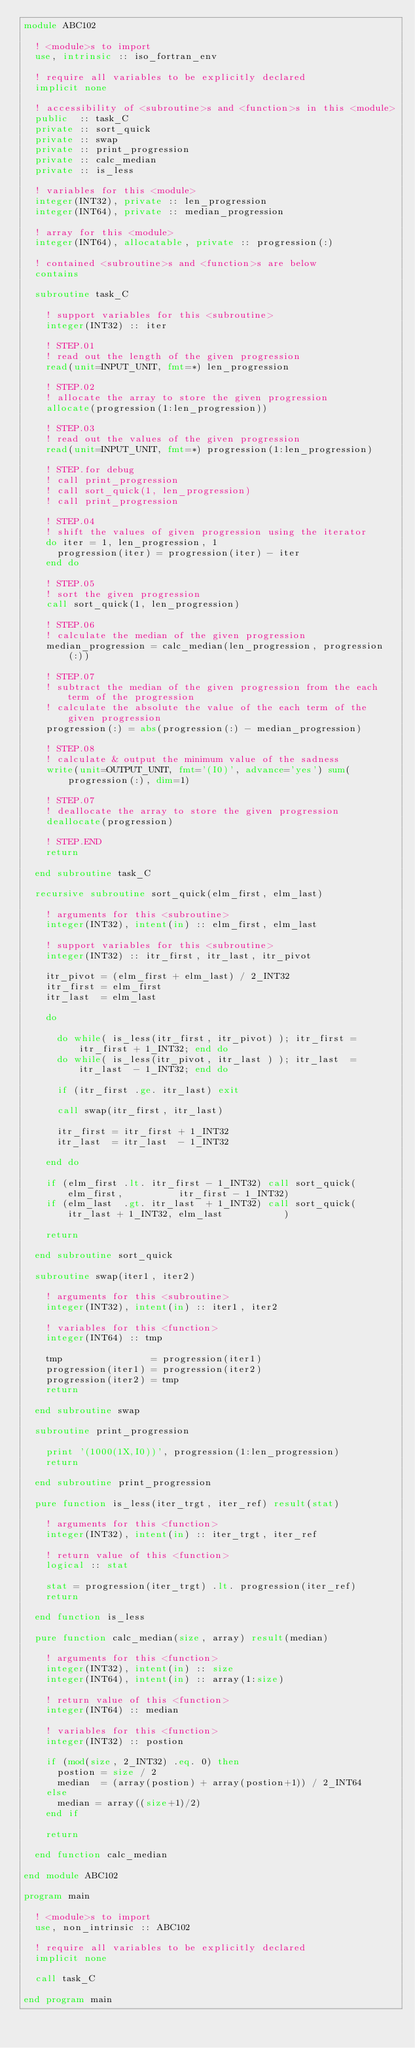Convert code to text. <code><loc_0><loc_0><loc_500><loc_500><_FORTRAN_>module ABC102

  ! <module>s to import
  use, intrinsic :: iso_fortran_env

  ! require all variables to be explicitly declared
  implicit none

  ! accessibility of <subroutine>s and <function>s in this <module>
  public  :: task_C
  private :: sort_quick
  private :: swap
  private :: print_progression
  private :: calc_median
  private :: is_less

  ! variables for this <module>
  integer(INT32), private :: len_progression
  integer(INT64), private :: median_progression

  ! array for this <module>
  integer(INT64), allocatable, private :: progression(:)

  ! contained <subroutine>s and <function>s are below
  contains

  subroutine task_C

    ! support variables for this <subroutine>
    integer(INT32) :: iter

    ! STEP.01
    ! read out the length of the given progression
    read(unit=INPUT_UNIT, fmt=*) len_progression

    ! STEP.02
    ! allocate the array to store the given progression
    allocate(progression(1:len_progression))

    ! STEP.03
    ! read out the values of the given progression
    read(unit=INPUT_UNIT, fmt=*) progression(1:len_progression)

    ! STEP.for debug
    ! call print_progression
    ! call sort_quick(1, len_progression)
    ! call print_progression

    ! STEP.04
    ! shift the values of given progression using the iterator
    do iter = 1, len_progression, 1
      progression(iter) = progression(iter) - iter
    end do

    ! STEP.05
    ! sort the given progression
    call sort_quick(1, len_progression)

    ! STEP.06
    ! calculate the median of the given progression
    median_progression = calc_median(len_progression, progression(:))

    ! STEP.07
    ! subtract the median of the given progression from the each term of the progression
    ! calculate the absolute the value of the each term of the given progression
    progression(:) = abs(progression(:) - median_progression)

    ! STEP.08
    ! calculate & output the minimum value of the sadness
    write(unit=OUTPUT_UNIT, fmt='(I0)', advance='yes') sum(progression(:), dim=1)

    ! STEP.07
    ! deallocate the array to store the given progression
    deallocate(progression)

    ! STEP.END
    return

  end subroutine task_C

  recursive subroutine sort_quick(elm_first, elm_last)

    ! arguments for this <subroutine>
    integer(INT32), intent(in) :: elm_first, elm_last

    ! support variables for this <subroutine>
    integer(INT32) :: itr_first, itr_last, itr_pivot

    itr_pivot = (elm_first + elm_last) / 2_INT32
    itr_first = elm_first
    itr_last  = elm_last

    do

      do while( is_less(itr_first, itr_pivot) ); itr_first = itr_first + 1_INT32; end do
      do while( is_less(itr_pivot, itr_last ) ); itr_last  = itr_last  - 1_INT32; end do

      if (itr_first .ge. itr_last) exit

      call swap(itr_first, itr_last)

      itr_first = itr_first + 1_INT32
      itr_last  = itr_last  - 1_INT32

    end do

    if (elm_first .lt. itr_first - 1_INT32) call sort_quick(elm_first,          itr_first - 1_INT32)
    if (elm_last  .gt. itr_last  + 1_INT32) call sort_quick(itr_last + 1_INT32, elm_last           )

    return

  end subroutine sort_quick

  subroutine swap(iter1, iter2)

    ! arguments for this <subroutine>
    integer(INT32), intent(in) :: iter1, iter2

    ! variables for this <function>
    integer(INT64) :: tmp

    tmp                = progression(iter1)
    progression(iter1) = progression(iter2)
    progression(iter2) = tmp
    return

  end subroutine swap

  subroutine print_progression

    print '(1000(1X,I0))', progression(1:len_progression)
    return

  end subroutine print_progression

  pure function is_less(iter_trgt, iter_ref) result(stat)

    ! arguments for this <function>
    integer(INT32), intent(in) :: iter_trgt, iter_ref

    ! return value of this <function>
    logical :: stat

    stat = progression(iter_trgt) .lt. progression(iter_ref)
    return

  end function is_less

  pure function calc_median(size, array) result(median)

    ! arguments for this <function>
    integer(INT32), intent(in) :: size
    integer(INT64), intent(in) :: array(1:size)

    ! return value of this <function>
    integer(INT64) :: median

    ! variables for this <function>
    integer(INT32) :: postion

    if (mod(size, 2_INT32) .eq. 0) then
      postion = size / 2
      median  = (array(postion) + array(postion+1)) / 2_INT64
    else
      median = array((size+1)/2)
    end if

    return

  end function calc_median

end module ABC102

program main

  ! <module>s to import
  use, non_intrinsic :: ABC102

  ! require all variables to be explicitly declared
  implicit none

  call task_C

end program main</code> 